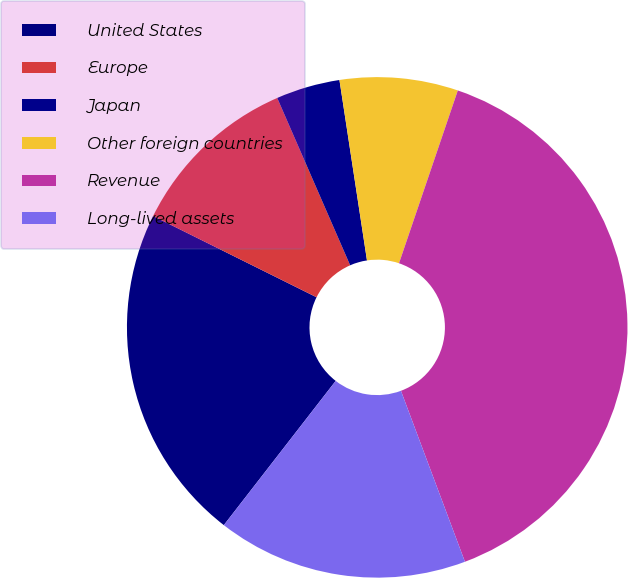<chart> <loc_0><loc_0><loc_500><loc_500><pie_chart><fcel>United States<fcel>Europe<fcel>Japan<fcel>Other foreign countries<fcel>Revenue<fcel>Long-lived assets<nl><fcel>21.84%<fcel>11.12%<fcel>4.13%<fcel>7.63%<fcel>39.08%<fcel>16.2%<nl></chart> 